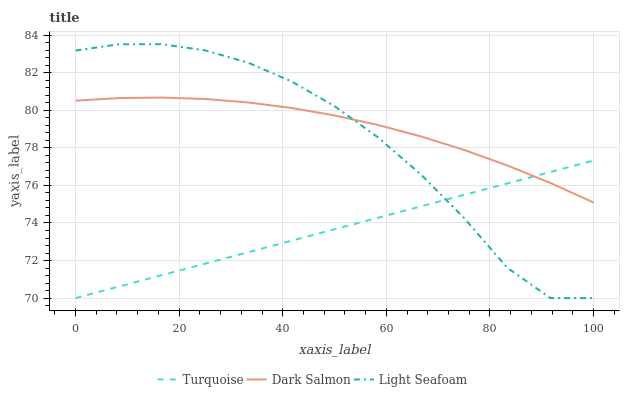Does Light Seafoam have the minimum area under the curve?
Answer yes or no. No. Does Light Seafoam have the maximum area under the curve?
Answer yes or no. No. Is Dark Salmon the smoothest?
Answer yes or no. No. Is Dark Salmon the roughest?
Answer yes or no. No. Does Dark Salmon have the lowest value?
Answer yes or no. No. Does Dark Salmon have the highest value?
Answer yes or no. No. 